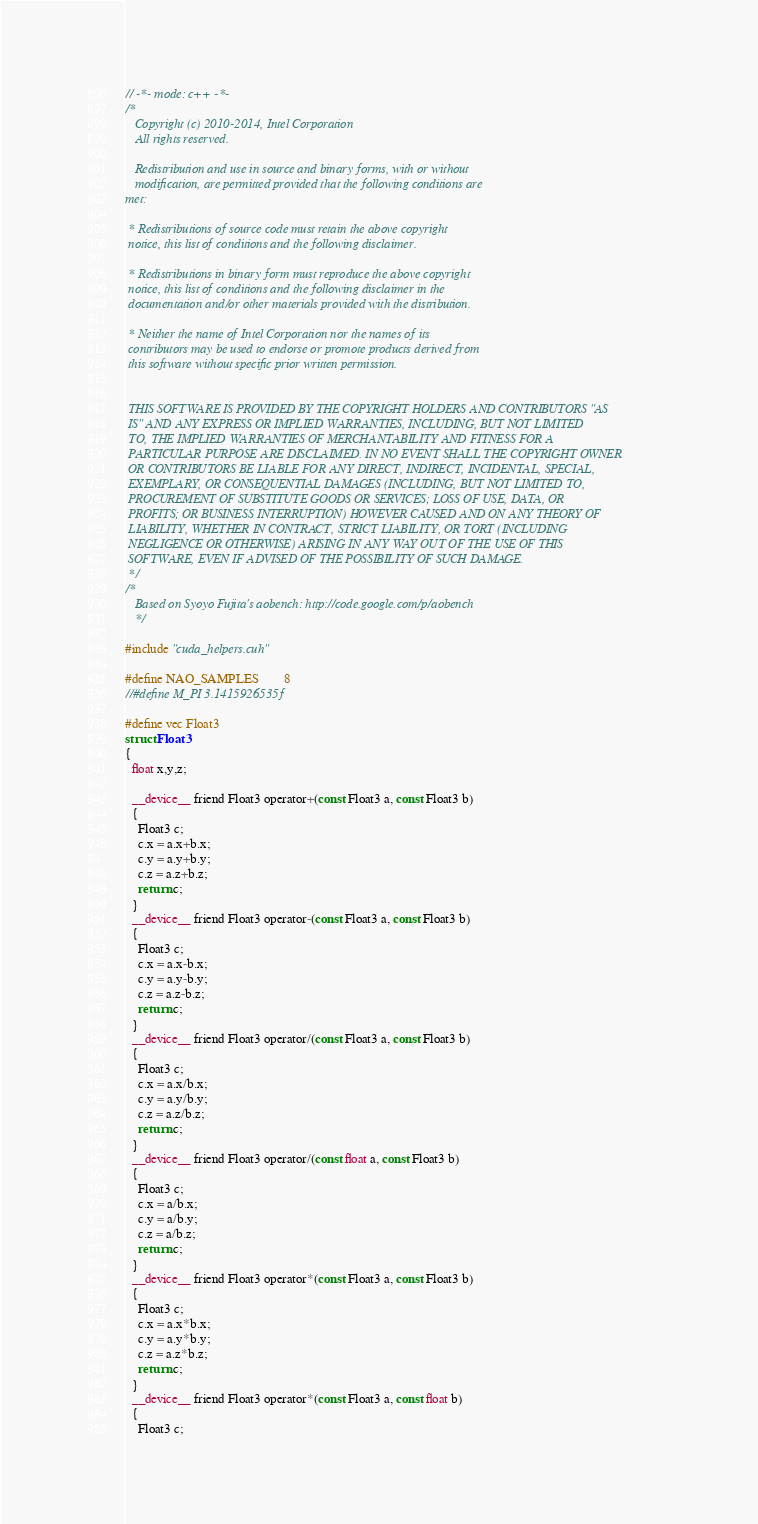<code> <loc_0><loc_0><loc_500><loc_500><_Cuda_>// -*- mode: c++ -*-
/*
   Copyright (c) 2010-2014, Intel Corporation
   All rights reserved.

   Redistribution and use in source and binary forms, with or without
   modification, are permitted provided that the following conditions are
met:

 * Redistributions of source code must retain the above copyright
 notice, this list of conditions and the following disclaimer.

 * Redistributions in binary form must reproduce the above copyright
 notice, this list of conditions and the following disclaimer in the
 documentation and/or other materials provided with the distribution.

 * Neither the name of Intel Corporation nor the names of its
 contributors may be used to endorse or promote products derived from
 this software without specific prior written permission.


 THIS SOFTWARE IS PROVIDED BY THE COPYRIGHT HOLDERS AND CONTRIBUTORS "AS
 IS" AND ANY EXPRESS OR IMPLIED WARRANTIES, INCLUDING, BUT NOT LIMITED
 TO, THE IMPLIED WARRANTIES OF MERCHANTABILITY AND FITNESS FOR A
 PARTICULAR PURPOSE ARE DISCLAIMED. IN NO EVENT SHALL THE COPYRIGHT OWNER
 OR CONTRIBUTORS BE LIABLE FOR ANY DIRECT, INDIRECT, INCIDENTAL, SPECIAL,
 EXEMPLARY, OR CONSEQUENTIAL DAMAGES (INCLUDING, BUT NOT LIMITED TO,
 PROCUREMENT OF SUBSTITUTE GOODS OR SERVICES; LOSS OF USE, DATA, OR
 PROFITS; OR BUSINESS INTERRUPTION) HOWEVER CAUSED AND ON ANY THEORY OF
 LIABILITY, WHETHER IN CONTRACT, STRICT LIABILITY, OR TORT (INCLUDING
 NEGLIGENCE OR OTHERWISE) ARISING IN ANY WAY OUT OF THE USE OF THIS
 SOFTWARE, EVEN IF ADVISED OF THE POSSIBILITY OF SUCH DAMAGE.
 */
/*
   Based on Syoyo Fujita's aobench: http://code.google.com/p/aobench
   */

#include "cuda_helpers.cuh"

#define NAO_SAMPLES        8
//#define M_PI 3.1415926535f

#define vec Float3
struct Float3
{
  float x,y,z;

  __device__ friend Float3 operator+(const Float3 a, const Float3 b)
  {
    Float3 c;
    c.x = a.x+b.x;
    c.y = a.y+b.y;
    c.z = a.z+b.z;
    return c;
  }
  __device__ friend Float3 operator-(const Float3 a, const Float3 b)
  {
    Float3 c;
    c.x = a.x-b.x;
    c.y = a.y-b.y;
    c.z = a.z-b.z;
    return c;
  }
  __device__ friend Float3 operator/(const Float3 a, const Float3 b)
  {
    Float3 c;
    c.x = a.x/b.x;
    c.y = a.y/b.y;
    c.z = a.z/b.z;
    return c;
  }
  __device__ friend Float3 operator/(const float a, const Float3 b)
  {
    Float3 c;
    c.x = a/b.x;
    c.y = a/b.y;
    c.z = a/b.z;
    return c;
  }
  __device__ friend Float3 operator*(const Float3 a, const Float3 b)
  {
    Float3 c;
    c.x = a.x*b.x;
    c.y = a.y*b.y;
    c.z = a.z*b.z;
    return c;
  }
  __device__ friend Float3 operator*(const Float3 a, const float b)
  {
    Float3 c;</code> 